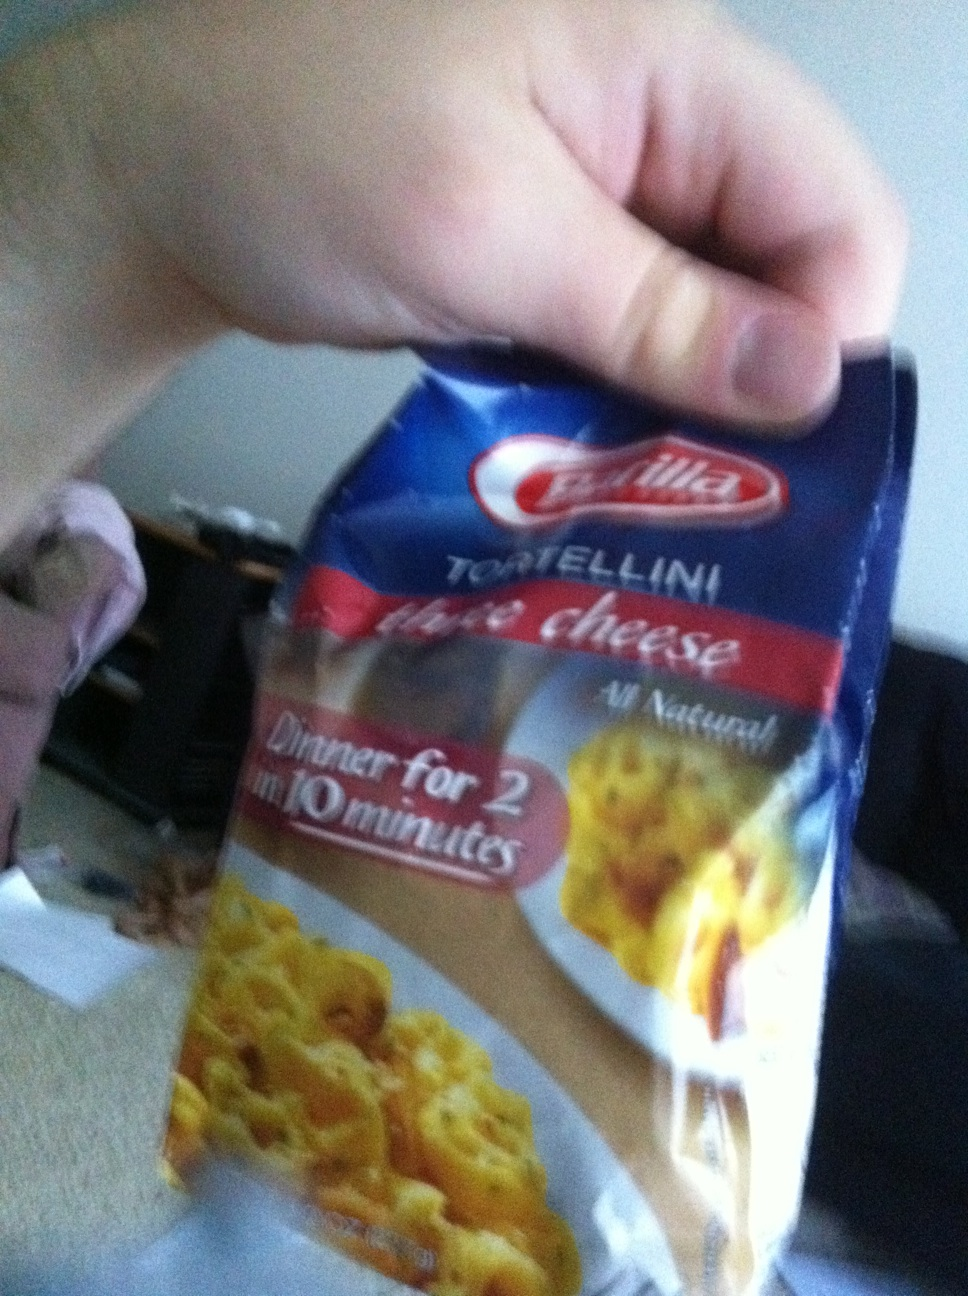If this tortellini could talk, what story would it tell about its journey from farm to table? If the Barilla three cheese tortellini could talk, it might tell a tale of a journey that begins in the lush, rolling fields of Italy where wheat is grown under the warm Mediterranean sun. This wheat is then carefully harvested and milled into premium semolina flour. Meanwhile, the milk from local dairy farms is transformed into rich ricotta, Parmigiano Reggiano, and Grana Padano cheeses. In a bustling pasta factory, the skilled pasta makers combine the flour and cheeses with love and tradition, shaping them into delicate tortellini. These little parcels of delight are then packaged and shipped across the globe, finally reaching the shelves of a local store near you. Once purchased, they rest briefly in a pantry before taking a plunge into boiling water, ready to be transformed into a comforting, delicious meal that brings warmth and joy to the table. Translate this story into an exciting children's adventure! In a magical land far away, in the heart of Pasta Valley, lived a cheerful group of Tortellinis. Led by Toni the Bold, the Tortellinis embarked on a grand adventure from their home fields where golden wheat danced in the sunlight to the Dairy Caves where the finest cheeses were made. Along the way, they faced thrilling challenges like crossing the River of Salty Tears and climbing Mount Floury Peak. With the help of wise old Chef Alfredo, who gave them a magical blend of ingredients, they turned into shiny, brave tortellinis ready for their mission. In the end, they were whisked away to homes around the world, where they brought smiles and stories of bravery and friendship to every dinner table they visited. 